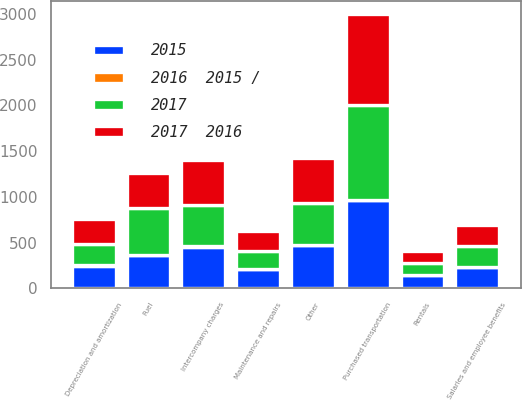Convert chart. <chart><loc_0><loc_0><loc_500><loc_500><stacked_bar_chart><ecel><fcel>Salaries and employee benefits<fcel>Purchased transportation<fcel>Rentals<fcel>Depreciation and amortization<fcel>Fuel<fcel>Maintenance and repairs<fcel>Intercompany charges<fcel>Other<nl><fcel>2017  2016<fcel>230<fcel>988<fcel>136<fcel>269<fcel>384<fcel>215<fcel>497<fcel>499<nl><fcel>2015<fcel>230<fcel>962<fcel>142<fcel>248<fcel>363<fcel>206<fcel>456<fcel>472<nl><fcel>2017<fcel>230<fcel>1045<fcel>129<fcel>230<fcel>508<fcel>201<fcel>444<fcel>452<nl><fcel>2016  2015 /<fcel>5<fcel>3<fcel>4<fcel>8<fcel>6<fcel>4<fcel>9<fcel>6<nl></chart> 